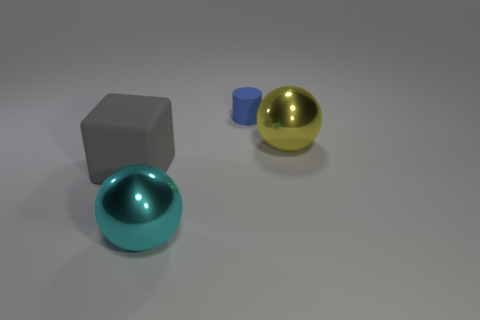Is there any other thing that is the same size as the rubber cylinder?
Make the answer very short. No. What is the color of the big metallic sphere that is on the left side of the metallic thing that is behind the big gray cube that is to the left of the blue cylinder?
Offer a terse response. Cyan. Is the material of the large cyan thing the same as the blue object?
Offer a very short reply. No. There is a tiny blue matte cylinder; how many large metallic spheres are left of it?
Your response must be concise. 1. There is another metal object that is the same shape as the yellow metallic object; what is its size?
Provide a succinct answer. Large. What number of cyan objects are either rubber objects or big objects?
Provide a short and direct response. 1. There is a gray cube that is in front of the yellow shiny sphere; what number of shiny spheres are in front of it?
Ensure brevity in your answer.  1. What number of other objects are there of the same shape as the cyan object?
Keep it short and to the point. 1. How many small things are the same color as the matte cylinder?
Your answer should be compact. 0. What is the color of the tiny object that is the same material as the cube?
Keep it short and to the point. Blue. 